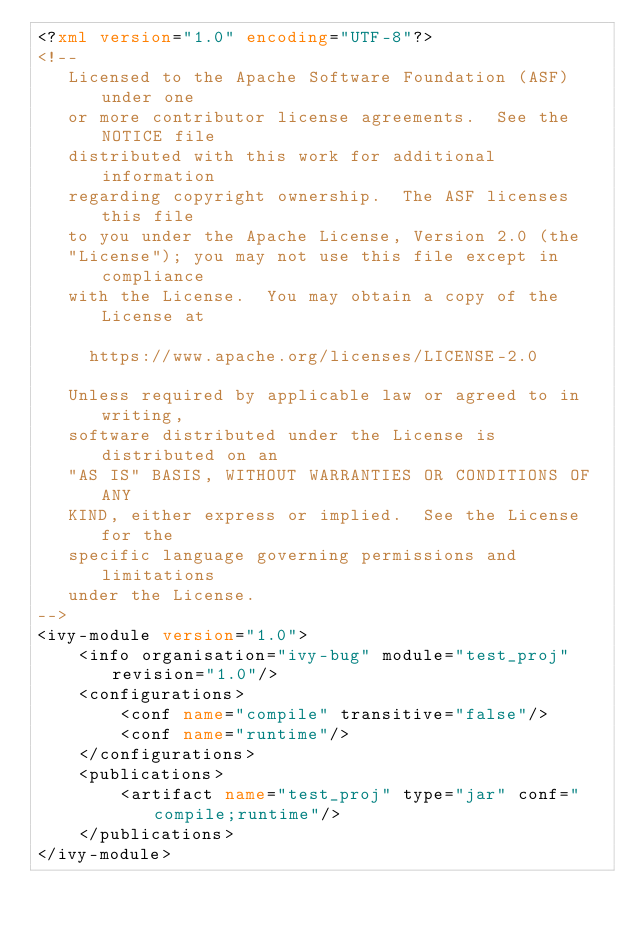<code> <loc_0><loc_0><loc_500><loc_500><_XML_><?xml version="1.0" encoding="UTF-8"?>
<!--
   Licensed to the Apache Software Foundation (ASF) under one
   or more contributor license agreements.  See the NOTICE file
   distributed with this work for additional information
   regarding copyright ownership.  The ASF licenses this file
   to you under the Apache License, Version 2.0 (the
   "License"); you may not use this file except in compliance
   with the License.  You may obtain a copy of the License at

     https://www.apache.org/licenses/LICENSE-2.0

   Unless required by applicable law or agreed to in writing,
   software distributed under the License is distributed on an
   "AS IS" BASIS, WITHOUT WARRANTIES OR CONDITIONS OF ANY
   KIND, either express or implied.  See the License for the
   specific language governing permissions and limitations
   under the License.    
-->
<ivy-module version="1.0">
	<info organisation="ivy-bug" module="test_proj" revision="1.0"/>
	<configurations>
		<conf name="compile" transitive="false"/>
		<conf name="runtime"/>
	</configurations>
	<publications>
		<artifact name="test_proj" type="jar" conf="compile;runtime"/>
	</publications>
</ivy-module>
</code> 